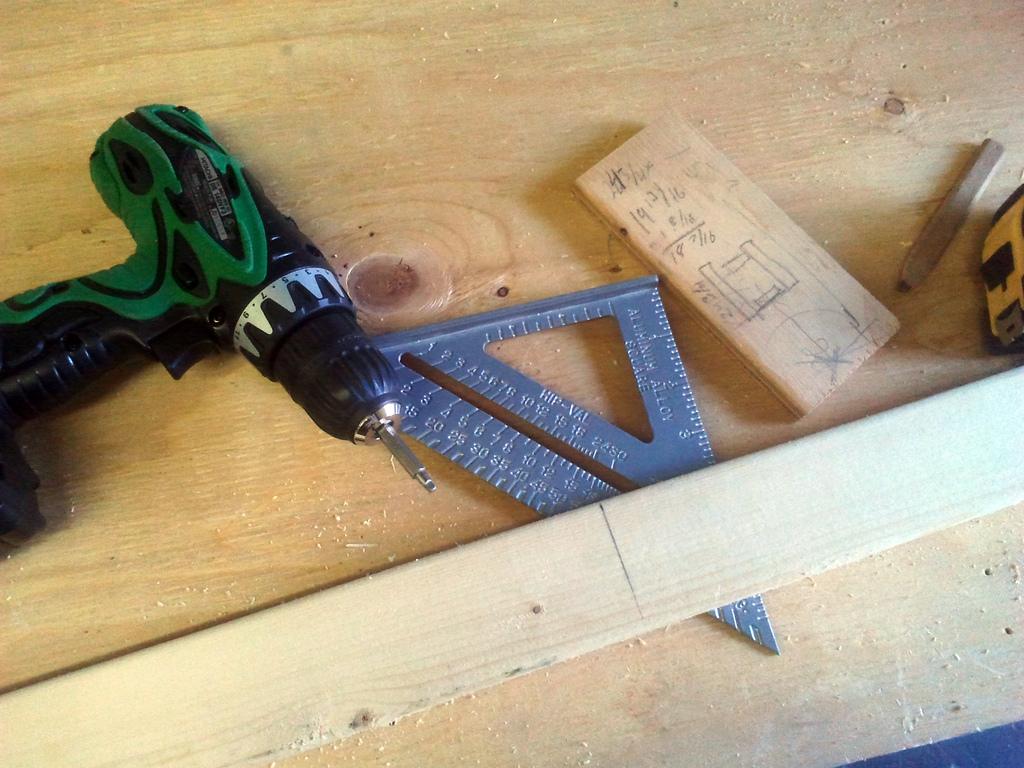To measure things?
Your response must be concise. Yes. 